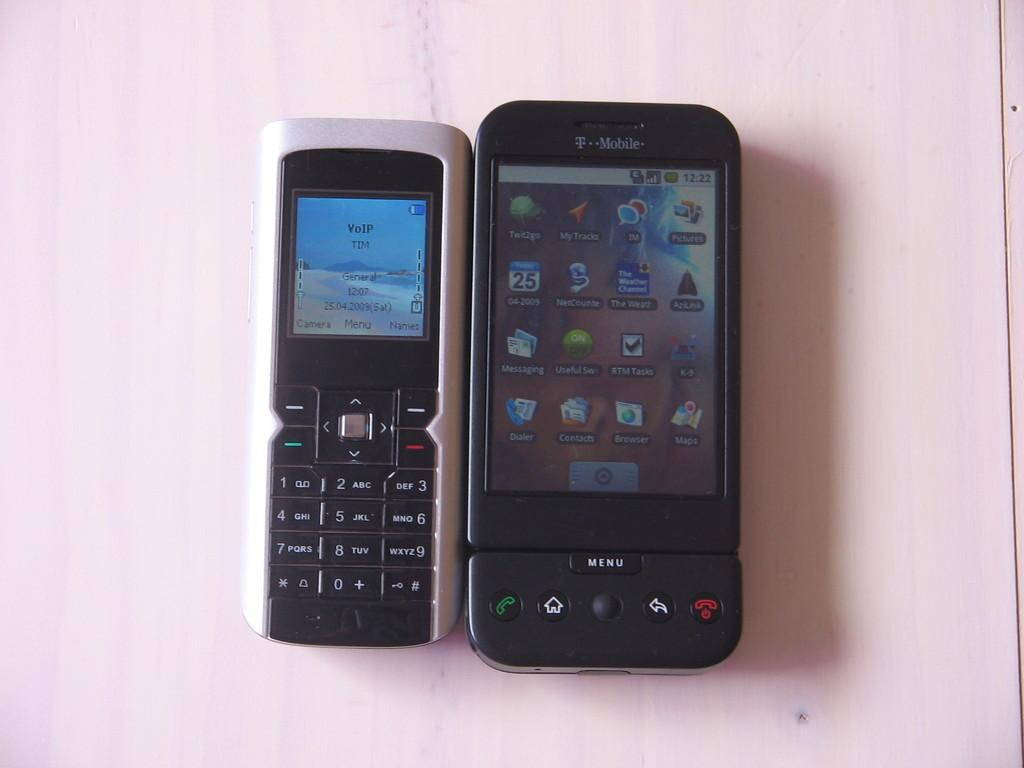<image>
Provide a brief description of the given image. An old fashioned phone next to a new one, the new one has t he word Menu at the bottom. 